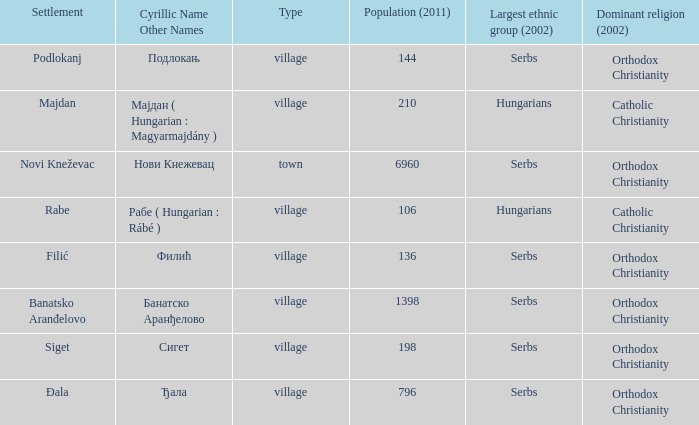What type of settlement is rabe? Village. 